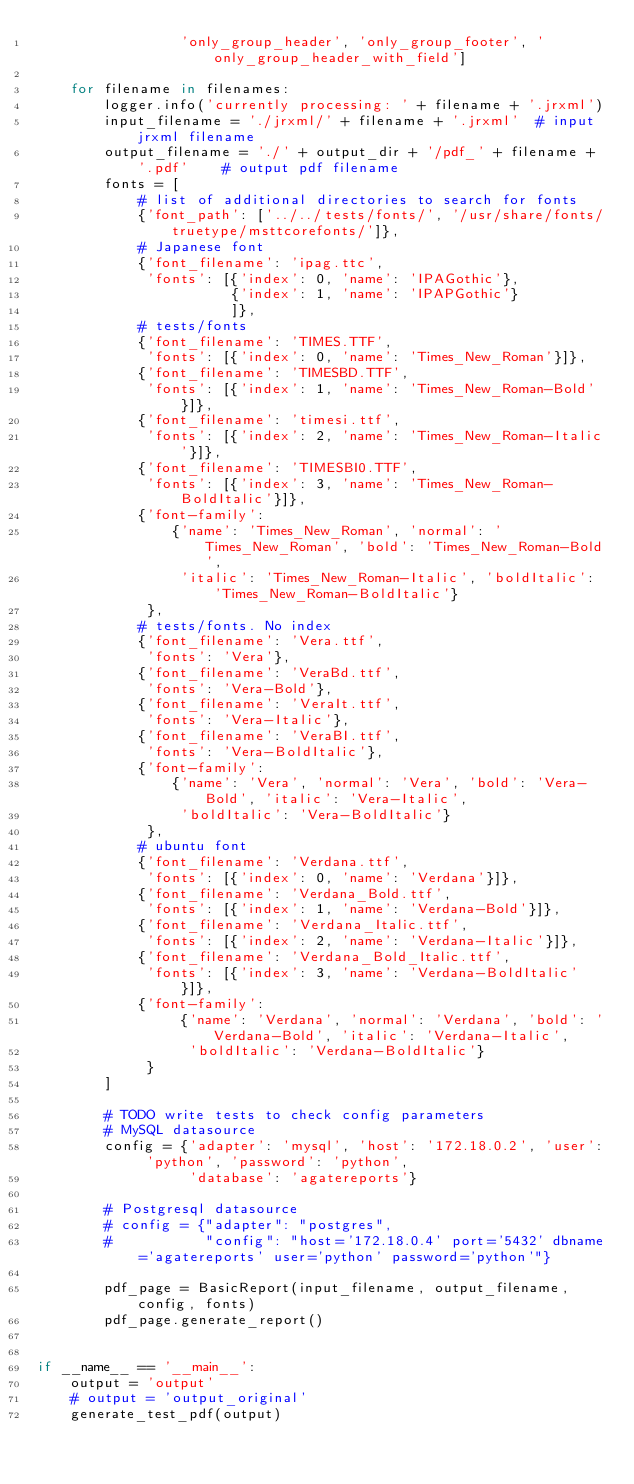<code> <loc_0><loc_0><loc_500><loc_500><_Python_>                 'only_group_header', 'only_group_footer', 'only_group_header_with_field']

    for filename in filenames:
        logger.info('currently processing: ' + filename + '.jrxml')
        input_filename = './jrxml/' + filename + '.jrxml'  # input jrxml filename
        output_filename = './' + output_dir + '/pdf_' + filename + '.pdf'    # output pdf filename
        fonts = [
            # list of additional directories to search for fonts
            {'font_path': ['../../tests/fonts/', '/usr/share/fonts/truetype/msttcorefonts/']},
            # Japanese font
            {'font_filename': 'ipag.ttc',
             'fonts': [{'index': 0, 'name': 'IPAGothic'},
                       {'index': 1, 'name': 'IPAPGothic'}
                       ]},
            # tests/fonts
            {'font_filename': 'TIMES.TTF',
             'fonts': [{'index': 0, 'name': 'Times_New_Roman'}]},
            {'font_filename': 'TIMESBD.TTF',
             'fonts': [{'index': 1, 'name': 'Times_New_Roman-Bold'}]},
            {'font_filename': 'timesi.ttf',
             'fonts': [{'index': 2, 'name': 'Times_New_Roman-Italic'}]},
            {'font_filename': 'TIMESBI0.TTF',
             'fonts': [{'index': 3, 'name': 'Times_New_Roman-BoldItalic'}]},
            {'font-family':
                {'name': 'Times_New_Roman', 'normal': 'Times_New_Roman', 'bold': 'Times_New_Roman-Bold',
                 'italic': 'Times_New_Roman-Italic', 'boldItalic': 'Times_New_Roman-BoldItalic'}
             },
            # tests/fonts. No index
            {'font_filename': 'Vera.ttf',
             'fonts': 'Vera'},
            {'font_filename': 'VeraBd.ttf',
             'fonts': 'Vera-Bold'},
            {'font_filename': 'VeraIt.ttf',
             'fonts': 'Vera-Italic'},
            {'font_filename': 'VeraBI.ttf',
             'fonts': 'Vera-BoldItalic'},
            {'font-family':
                {'name': 'Vera', 'normal': 'Vera', 'bold': 'Vera-Bold', 'italic': 'Vera-Italic',
                 'boldItalic': 'Vera-BoldItalic'}
             },
            # ubuntu font
            {'font_filename': 'Verdana.ttf',
             'fonts': [{'index': 0, 'name': 'Verdana'}]},
            {'font_filename': 'Verdana_Bold.ttf',
             'fonts': [{'index': 1, 'name': 'Verdana-Bold'}]},
            {'font_filename': 'Verdana_Italic.ttf',
             'fonts': [{'index': 2, 'name': 'Verdana-Italic'}]},
            {'font_filename': 'Verdana_Bold_Italic.ttf',
             'fonts': [{'index': 3, 'name': 'Verdana-BoldItalic'}]},
            {'font-family':
                 {'name': 'Verdana', 'normal': 'Verdana', 'bold': 'Verdana-Bold', 'italic': 'Verdana-Italic',
                  'boldItalic': 'Verdana-BoldItalic'}
             }
        ]

        # TODO write tests to check config parameters
        # MySQL datasource
        config = {'adapter': 'mysql', 'host': '172.18.0.2', 'user': 'python', 'password': 'python',
                  'database': 'agatereports'}

        # Postgresql datasource
        # config = {"adapter": "postgres",
        #           "config": "host='172.18.0.4' port='5432' dbname='agatereports' user='python' password='python'"}

        pdf_page = BasicReport(input_filename, output_filename, config, fonts)
        pdf_page.generate_report()


if __name__ == '__main__':
    output = 'output'
    # output = 'output_original'
    generate_test_pdf(output)
</code> 